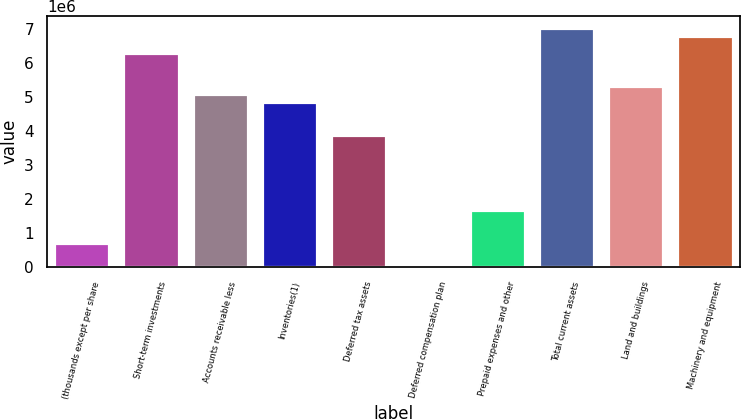Convert chart to OTSL. <chart><loc_0><loc_0><loc_500><loc_500><bar_chart><fcel>(thousands except per share<fcel>Short-term investments<fcel>Accounts receivable less<fcel>Inventories(1)<fcel>Deferred tax assets<fcel>Deferred compensation plan<fcel>Prepaid expenses and other<fcel>Total current assets<fcel>Land and buildings<fcel>Machinery and equipment<nl><fcel>726738<fcel>6.29118e+06<fcel>5.08152e+06<fcel>4.83958e+06<fcel>3.87186e+06<fcel>942<fcel>1.69447e+06<fcel>7.01697e+06<fcel>5.32345e+06<fcel>6.77504e+06<nl></chart> 